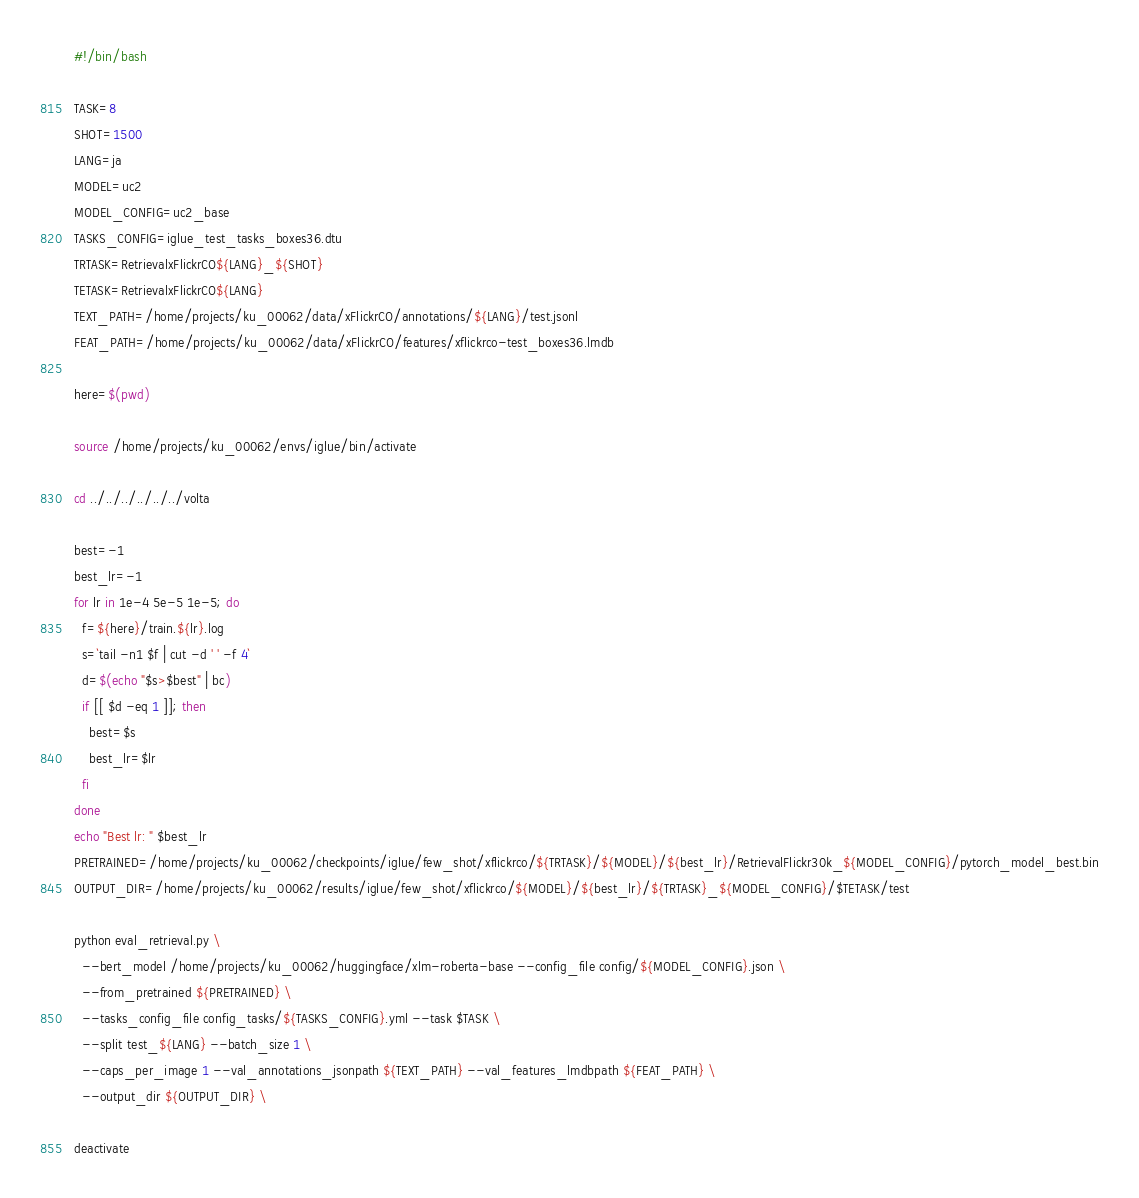<code> <loc_0><loc_0><loc_500><loc_500><_Bash_>#!/bin/bash

TASK=8
SHOT=1500
LANG=ja
MODEL=uc2
MODEL_CONFIG=uc2_base
TASKS_CONFIG=iglue_test_tasks_boxes36.dtu
TRTASK=RetrievalxFlickrCO${LANG}_${SHOT}
TETASK=RetrievalxFlickrCO${LANG}
TEXT_PATH=/home/projects/ku_00062/data/xFlickrCO/annotations/${LANG}/test.jsonl
FEAT_PATH=/home/projects/ku_00062/data/xFlickrCO/features/xflickrco-test_boxes36.lmdb

here=$(pwd)

source /home/projects/ku_00062/envs/iglue/bin/activate

cd ../../../../../../volta

best=-1
best_lr=-1
for lr in 1e-4 5e-5 1e-5; do
  f=${here}/train.${lr}.log
  s=`tail -n1 $f | cut -d ' ' -f 4`
  d=$(echo "$s>$best" | bc)
  if [[ $d -eq 1 ]]; then
    best=$s
    best_lr=$lr
  fi
done
echo "Best lr: " $best_lr
PRETRAINED=/home/projects/ku_00062/checkpoints/iglue/few_shot/xflickrco/${TRTASK}/${MODEL}/${best_lr}/RetrievalFlickr30k_${MODEL_CONFIG}/pytorch_model_best.bin
OUTPUT_DIR=/home/projects/ku_00062/results/iglue/few_shot/xflickrco/${MODEL}/${best_lr}/${TRTASK}_${MODEL_CONFIG}/$TETASK/test

python eval_retrieval.py \
  --bert_model /home/projects/ku_00062/huggingface/xlm-roberta-base --config_file config/${MODEL_CONFIG}.json \
  --from_pretrained ${PRETRAINED} \
  --tasks_config_file config_tasks/${TASKS_CONFIG}.yml --task $TASK \
  --split test_${LANG} --batch_size 1 \
  --caps_per_image 1 --val_annotations_jsonpath ${TEXT_PATH} --val_features_lmdbpath ${FEAT_PATH} \
  --output_dir ${OUTPUT_DIR} \

deactivate
</code> 